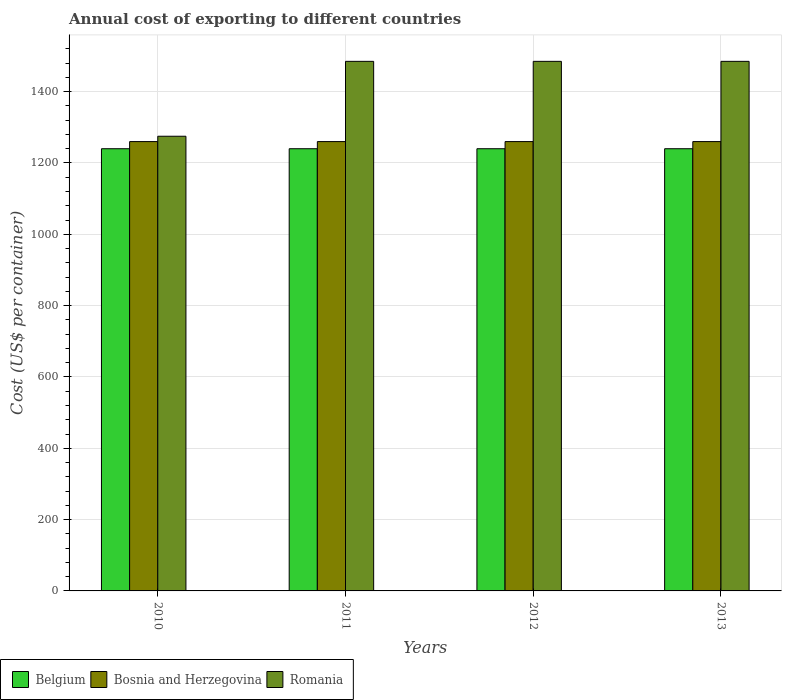How many different coloured bars are there?
Provide a short and direct response. 3. How many groups of bars are there?
Ensure brevity in your answer.  4. Are the number of bars on each tick of the X-axis equal?
Your answer should be very brief. Yes. What is the label of the 1st group of bars from the left?
Provide a short and direct response. 2010. What is the total annual cost of exporting in Belgium in 2010?
Provide a short and direct response. 1240. Across all years, what is the maximum total annual cost of exporting in Romania?
Ensure brevity in your answer.  1485. Across all years, what is the minimum total annual cost of exporting in Belgium?
Keep it short and to the point. 1240. In which year was the total annual cost of exporting in Romania maximum?
Your answer should be very brief. 2011. What is the total total annual cost of exporting in Romania in the graph?
Your response must be concise. 5730. What is the difference between the total annual cost of exporting in Belgium in 2010 and that in 2013?
Your answer should be compact. 0. What is the difference between the total annual cost of exporting in Belgium in 2011 and the total annual cost of exporting in Bosnia and Herzegovina in 2013?
Give a very brief answer. -20. What is the average total annual cost of exporting in Bosnia and Herzegovina per year?
Your answer should be very brief. 1260. In the year 2013, what is the difference between the total annual cost of exporting in Belgium and total annual cost of exporting in Romania?
Ensure brevity in your answer.  -245. In how many years, is the total annual cost of exporting in Romania greater than 720 US$?
Your response must be concise. 4. What is the ratio of the total annual cost of exporting in Bosnia and Herzegovina in 2012 to that in 2013?
Ensure brevity in your answer.  1. Is the total annual cost of exporting in Belgium in 2012 less than that in 2013?
Offer a terse response. No. Is the difference between the total annual cost of exporting in Belgium in 2010 and 2011 greater than the difference between the total annual cost of exporting in Romania in 2010 and 2011?
Your response must be concise. Yes. What is the difference between the highest and the lowest total annual cost of exporting in Bosnia and Herzegovina?
Ensure brevity in your answer.  0. In how many years, is the total annual cost of exporting in Bosnia and Herzegovina greater than the average total annual cost of exporting in Bosnia and Herzegovina taken over all years?
Offer a very short reply. 0. What does the 2nd bar from the left in 2011 represents?
Make the answer very short. Bosnia and Herzegovina. What does the 3rd bar from the right in 2010 represents?
Make the answer very short. Belgium. Is it the case that in every year, the sum of the total annual cost of exporting in Bosnia and Herzegovina and total annual cost of exporting in Romania is greater than the total annual cost of exporting in Belgium?
Give a very brief answer. Yes. What is the difference between two consecutive major ticks on the Y-axis?
Your response must be concise. 200. Does the graph contain any zero values?
Your answer should be compact. No. Does the graph contain grids?
Provide a succinct answer. Yes. Where does the legend appear in the graph?
Ensure brevity in your answer.  Bottom left. What is the title of the graph?
Keep it short and to the point. Annual cost of exporting to different countries. What is the label or title of the X-axis?
Give a very brief answer. Years. What is the label or title of the Y-axis?
Give a very brief answer. Cost (US$ per container). What is the Cost (US$ per container) in Belgium in 2010?
Your response must be concise. 1240. What is the Cost (US$ per container) of Bosnia and Herzegovina in 2010?
Your answer should be compact. 1260. What is the Cost (US$ per container) of Romania in 2010?
Provide a short and direct response. 1275. What is the Cost (US$ per container) of Belgium in 2011?
Ensure brevity in your answer.  1240. What is the Cost (US$ per container) in Bosnia and Herzegovina in 2011?
Give a very brief answer. 1260. What is the Cost (US$ per container) in Romania in 2011?
Your answer should be very brief. 1485. What is the Cost (US$ per container) of Belgium in 2012?
Provide a succinct answer. 1240. What is the Cost (US$ per container) in Bosnia and Herzegovina in 2012?
Offer a very short reply. 1260. What is the Cost (US$ per container) of Romania in 2012?
Offer a very short reply. 1485. What is the Cost (US$ per container) of Belgium in 2013?
Make the answer very short. 1240. What is the Cost (US$ per container) of Bosnia and Herzegovina in 2013?
Your answer should be compact. 1260. What is the Cost (US$ per container) in Romania in 2013?
Your answer should be very brief. 1485. Across all years, what is the maximum Cost (US$ per container) of Belgium?
Your answer should be compact. 1240. Across all years, what is the maximum Cost (US$ per container) in Bosnia and Herzegovina?
Offer a very short reply. 1260. Across all years, what is the maximum Cost (US$ per container) in Romania?
Your answer should be very brief. 1485. Across all years, what is the minimum Cost (US$ per container) in Belgium?
Your response must be concise. 1240. Across all years, what is the minimum Cost (US$ per container) in Bosnia and Herzegovina?
Keep it short and to the point. 1260. Across all years, what is the minimum Cost (US$ per container) in Romania?
Make the answer very short. 1275. What is the total Cost (US$ per container) in Belgium in the graph?
Offer a very short reply. 4960. What is the total Cost (US$ per container) of Bosnia and Herzegovina in the graph?
Ensure brevity in your answer.  5040. What is the total Cost (US$ per container) of Romania in the graph?
Your response must be concise. 5730. What is the difference between the Cost (US$ per container) in Romania in 2010 and that in 2011?
Your response must be concise. -210. What is the difference between the Cost (US$ per container) of Bosnia and Herzegovina in 2010 and that in 2012?
Keep it short and to the point. 0. What is the difference between the Cost (US$ per container) of Romania in 2010 and that in 2012?
Provide a succinct answer. -210. What is the difference between the Cost (US$ per container) in Belgium in 2010 and that in 2013?
Provide a succinct answer. 0. What is the difference between the Cost (US$ per container) in Bosnia and Herzegovina in 2010 and that in 2013?
Ensure brevity in your answer.  0. What is the difference between the Cost (US$ per container) of Romania in 2010 and that in 2013?
Offer a very short reply. -210. What is the difference between the Cost (US$ per container) in Bosnia and Herzegovina in 2011 and that in 2013?
Keep it short and to the point. 0. What is the difference between the Cost (US$ per container) of Belgium in 2012 and that in 2013?
Offer a terse response. 0. What is the difference between the Cost (US$ per container) of Belgium in 2010 and the Cost (US$ per container) of Romania in 2011?
Offer a terse response. -245. What is the difference between the Cost (US$ per container) of Bosnia and Herzegovina in 2010 and the Cost (US$ per container) of Romania in 2011?
Your response must be concise. -225. What is the difference between the Cost (US$ per container) of Belgium in 2010 and the Cost (US$ per container) of Romania in 2012?
Your answer should be very brief. -245. What is the difference between the Cost (US$ per container) of Bosnia and Herzegovina in 2010 and the Cost (US$ per container) of Romania in 2012?
Ensure brevity in your answer.  -225. What is the difference between the Cost (US$ per container) of Belgium in 2010 and the Cost (US$ per container) of Romania in 2013?
Make the answer very short. -245. What is the difference between the Cost (US$ per container) of Bosnia and Herzegovina in 2010 and the Cost (US$ per container) of Romania in 2013?
Your answer should be compact. -225. What is the difference between the Cost (US$ per container) in Belgium in 2011 and the Cost (US$ per container) in Romania in 2012?
Your answer should be compact. -245. What is the difference between the Cost (US$ per container) of Bosnia and Herzegovina in 2011 and the Cost (US$ per container) of Romania in 2012?
Provide a succinct answer. -225. What is the difference between the Cost (US$ per container) of Belgium in 2011 and the Cost (US$ per container) of Romania in 2013?
Your answer should be compact. -245. What is the difference between the Cost (US$ per container) in Bosnia and Herzegovina in 2011 and the Cost (US$ per container) in Romania in 2013?
Ensure brevity in your answer.  -225. What is the difference between the Cost (US$ per container) in Belgium in 2012 and the Cost (US$ per container) in Romania in 2013?
Give a very brief answer. -245. What is the difference between the Cost (US$ per container) in Bosnia and Herzegovina in 2012 and the Cost (US$ per container) in Romania in 2013?
Give a very brief answer. -225. What is the average Cost (US$ per container) in Belgium per year?
Ensure brevity in your answer.  1240. What is the average Cost (US$ per container) of Bosnia and Herzegovina per year?
Your response must be concise. 1260. What is the average Cost (US$ per container) in Romania per year?
Your response must be concise. 1432.5. In the year 2010, what is the difference between the Cost (US$ per container) in Belgium and Cost (US$ per container) in Romania?
Your response must be concise. -35. In the year 2011, what is the difference between the Cost (US$ per container) of Belgium and Cost (US$ per container) of Romania?
Your answer should be very brief. -245. In the year 2011, what is the difference between the Cost (US$ per container) of Bosnia and Herzegovina and Cost (US$ per container) of Romania?
Give a very brief answer. -225. In the year 2012, what is the difference between the Cost (US$ per container) in Belgium and Cost (US$ per container) in Romania?
Offer a terse response. -245. In the year 2012, what is the difference between the Cost (US$ per container) of Bosnia and Herzegovina and Cost (US$ per container) of Romania?
Ensure brevity in your answer.  -225. In the year 2013, what is the difference between the Cost (US$ per container) of Belgium and Cost (US$ per container) of Bosnia and Herzegovina?
Your answer should be very brief. -20. In the year 2013, what is the difference between the Cost (US$ per container) of Belgium and Cost (US$ per container) of Romania?
Your answer should be compact. -245. In the year 2013, what is the difference between the Cost (US$ per container) in Bosnia and Herzegovina and Cost (US$ per container) in Romania?
Make the answer very short. -225. What is the ratio of the Cost (US$ per container) of Belgium in 2010 to that in 2011?
Keep it short and to the point. 1. What is the ratio of the Cost (US$ per container) of Romania in 2010 to that in 2011?
Offer a very short reply. 0.86. What is the ratio of the Cost (US$ per container) in Bosnia and Herzegovina in 2010 to that in 2012?
Provide a succinct answer. 1. What is the ratio of the Cost (US$ per container) of Romania in 2010 to that in 2012?
Make the answer very short. 0.86. What is the ratio of the Cost (US$ per container) in Bosnia and Herzegovina in 2010 to that in 2013?
Make the answer very short. 1. What is the ratio of the Cost (US$ per container) in Romania in 2010 to that in 2013?
Offer a very short reply. 0.86. What is the ratio of the Cost (US$ per container) in Belgium in 2011 to that in 2012?
Ensure brevity in your answer.  1. What is the ratio of the Cost (US$ per container) in Romania in 2012 to that in 2013?
Keep it short and to the point. 1. What is the difference between the highest and the second highest Cost (US$ per container) in Belgium?
Your answer should be very brief. 0. What is the difference between the highest and the second highest Cost (US$ per container) in Bosnia and Herzegovina?
Keep it short and to the point. 0. What is the difference between the highest and the second highest Cost (US$ per container) in Romania?
Offer a terse response. 0. What is the difference between the highest and the lowest Cost (US$ per container) in Belgium?
Give a very brief answer. 0. What is the difference between the highest and the lowest Cost (US$ per container) in Bosnia and Herzegovina?
Your answer should be compact. 0. What is the difference between the highest and the lowest Cost (US$ per container) of Romania?
Give a very brief answer. 210. 